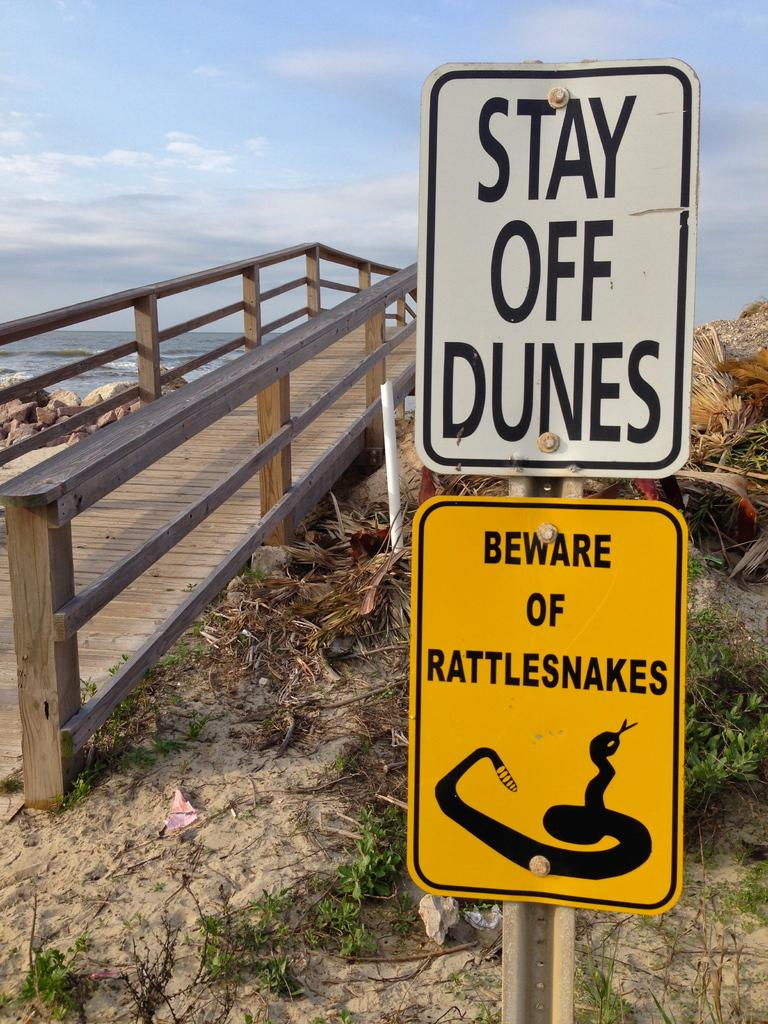<image>
Present a compact description of the photo's key features. An image of a beach scene and signs telling visitors to stay off the dunes. 